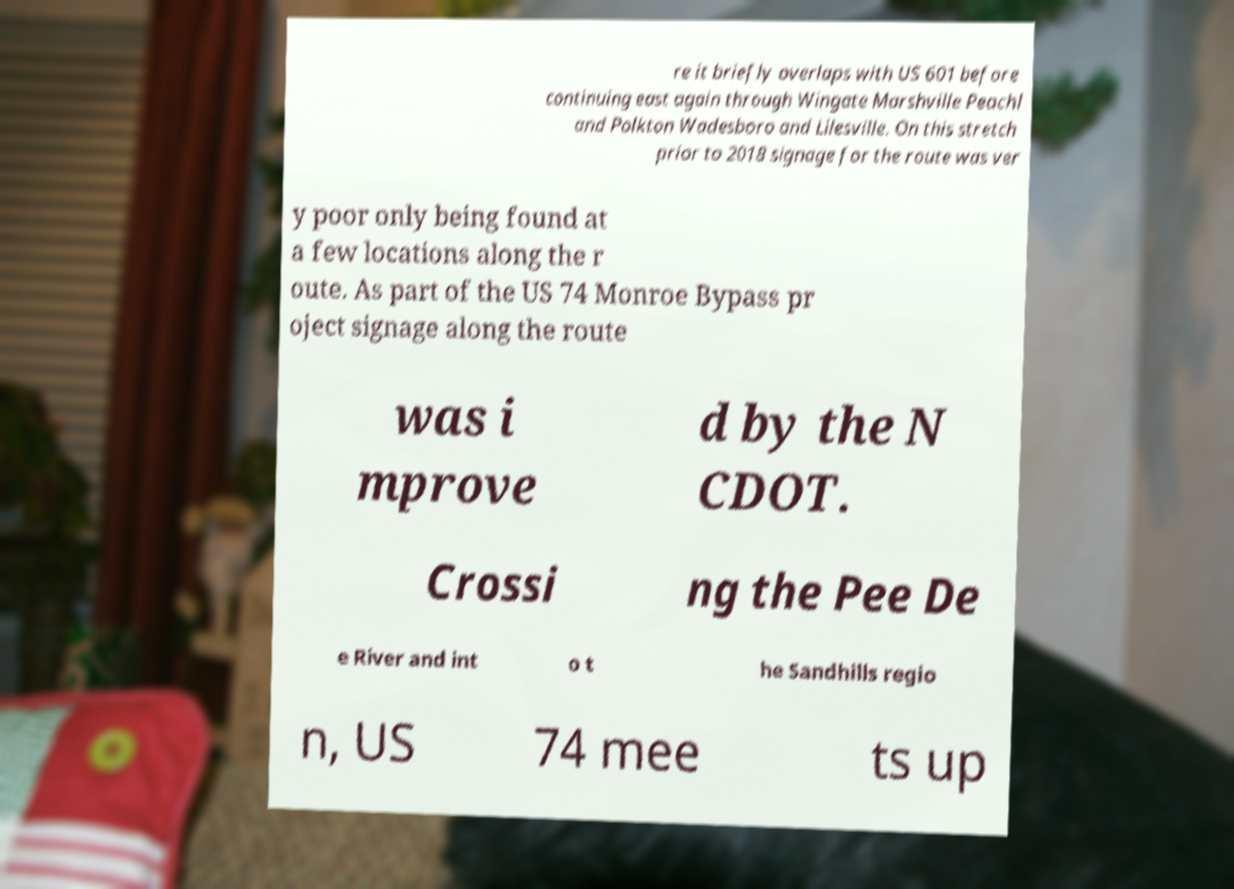Can you read and provide the text displayed in the image?This photo seems to have some interesting text. Can you extract and type it out for me? re it briefly overlaps with US 601 before continuing east again through Wingate Marshville Peachl and Polkton Wadesboro and Lilesville. On this stretch prior to 2018 signage for the route was ver y poor only being found at a few locations along the r oute. As part of the US 74 Monroe Bypass pr oject signage along the route was i mprove d by the N CDOT. Crossi ng the Pee De e River and int o t he Sandhills regio n, US 74 mee ts up 